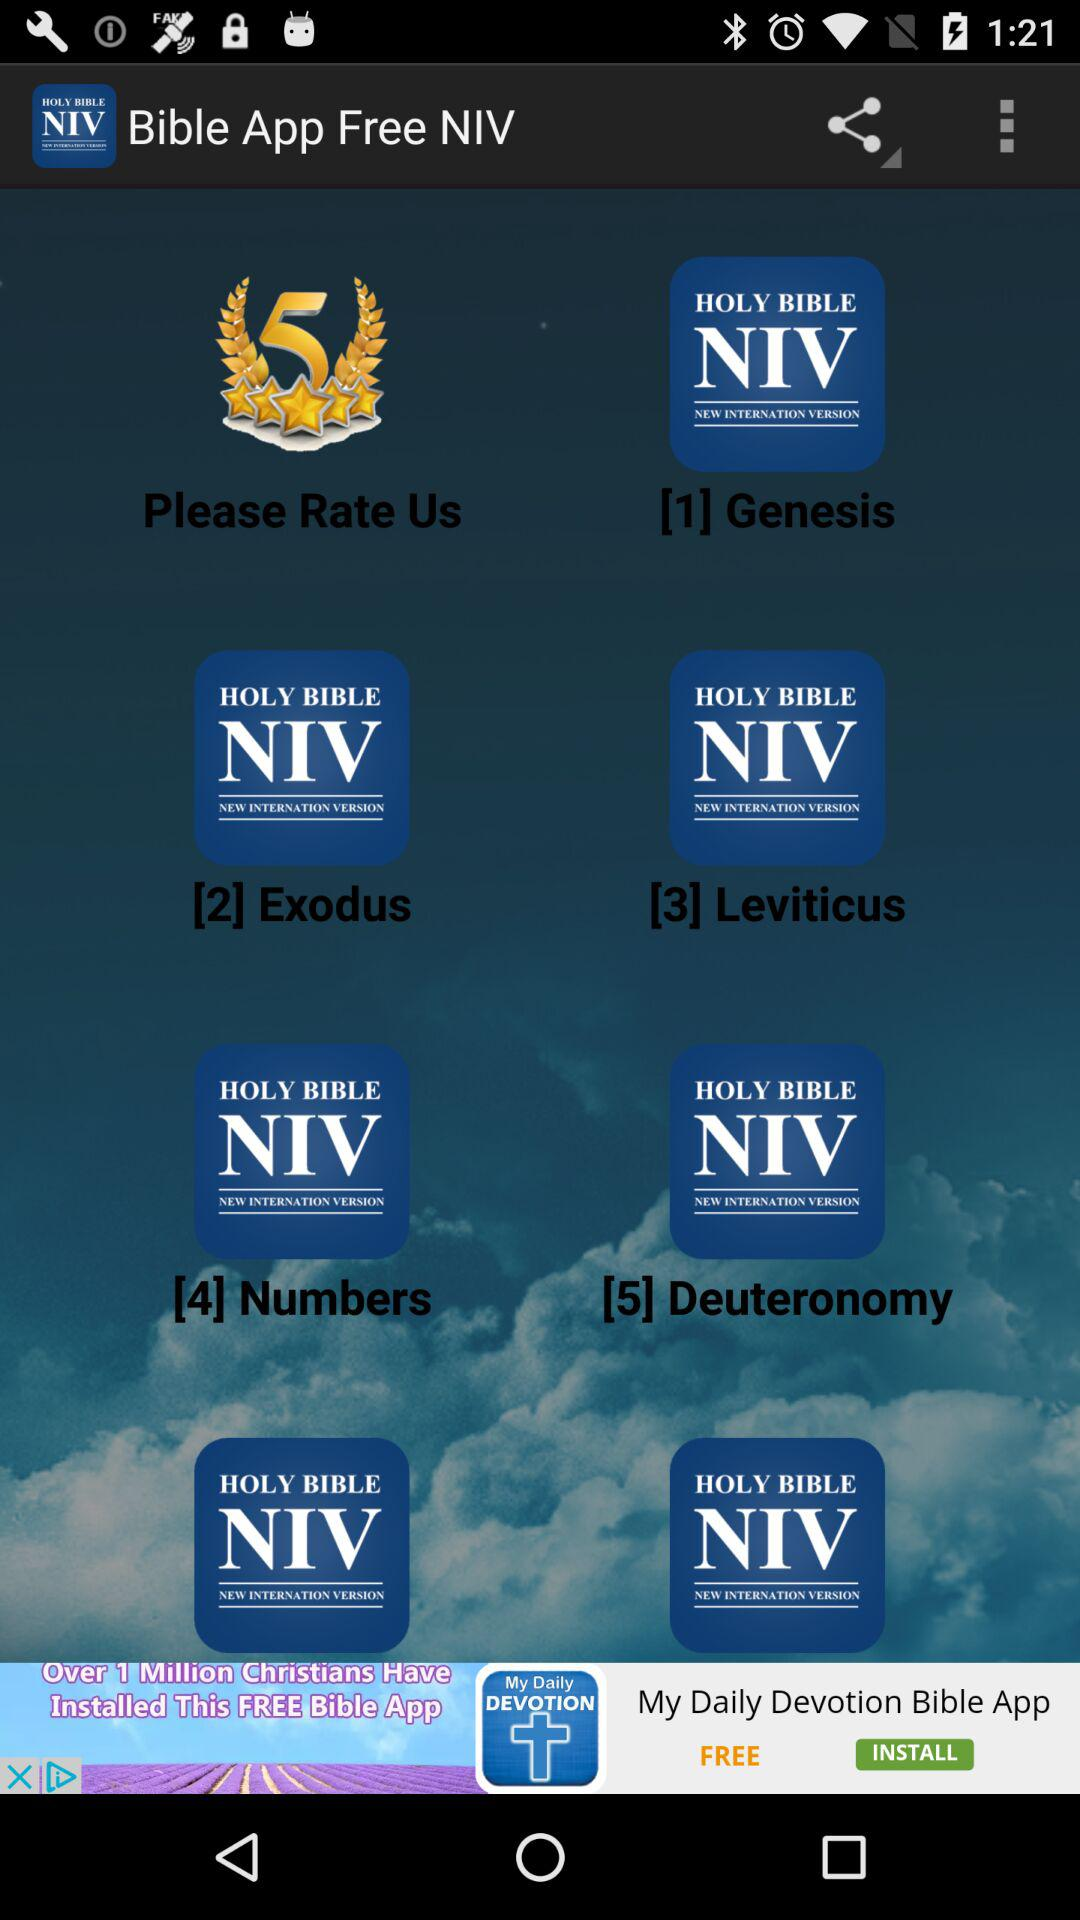How many people have reviewed this free Bible application?
When the provided information is insufficient, respond with <no answer>. <no answer> 